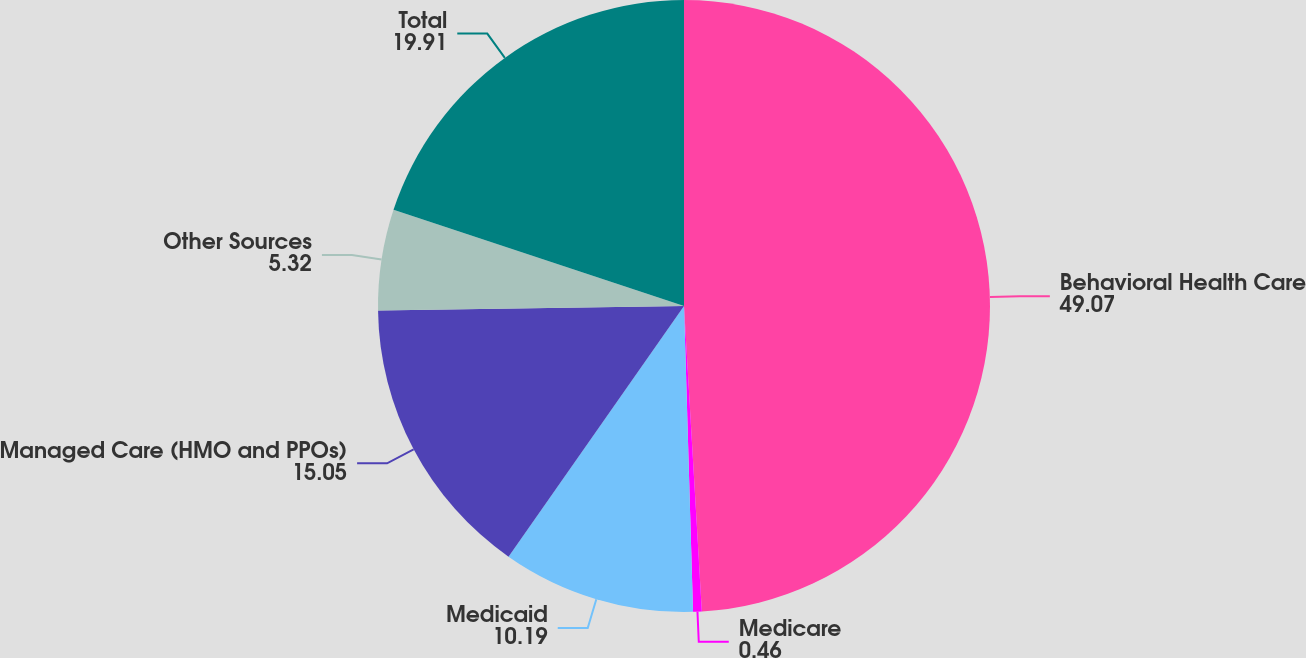Convert chart to OTSL. <chart><loc_0><loc_0><loc_500><loc_500><pie_chart><fcel>Behavioral Health Care<fcel>Medicare<fcel>Medicaid<fcel>Managed Care (HMO and PPOs)<fcel>Other Sources<fcel>Total<nl><fcel>49.07%<fcel>0.46%<fcel>10.19%<fcel>15.05%<fcel>5.32%<fcel>19.91%<nl></chart> 